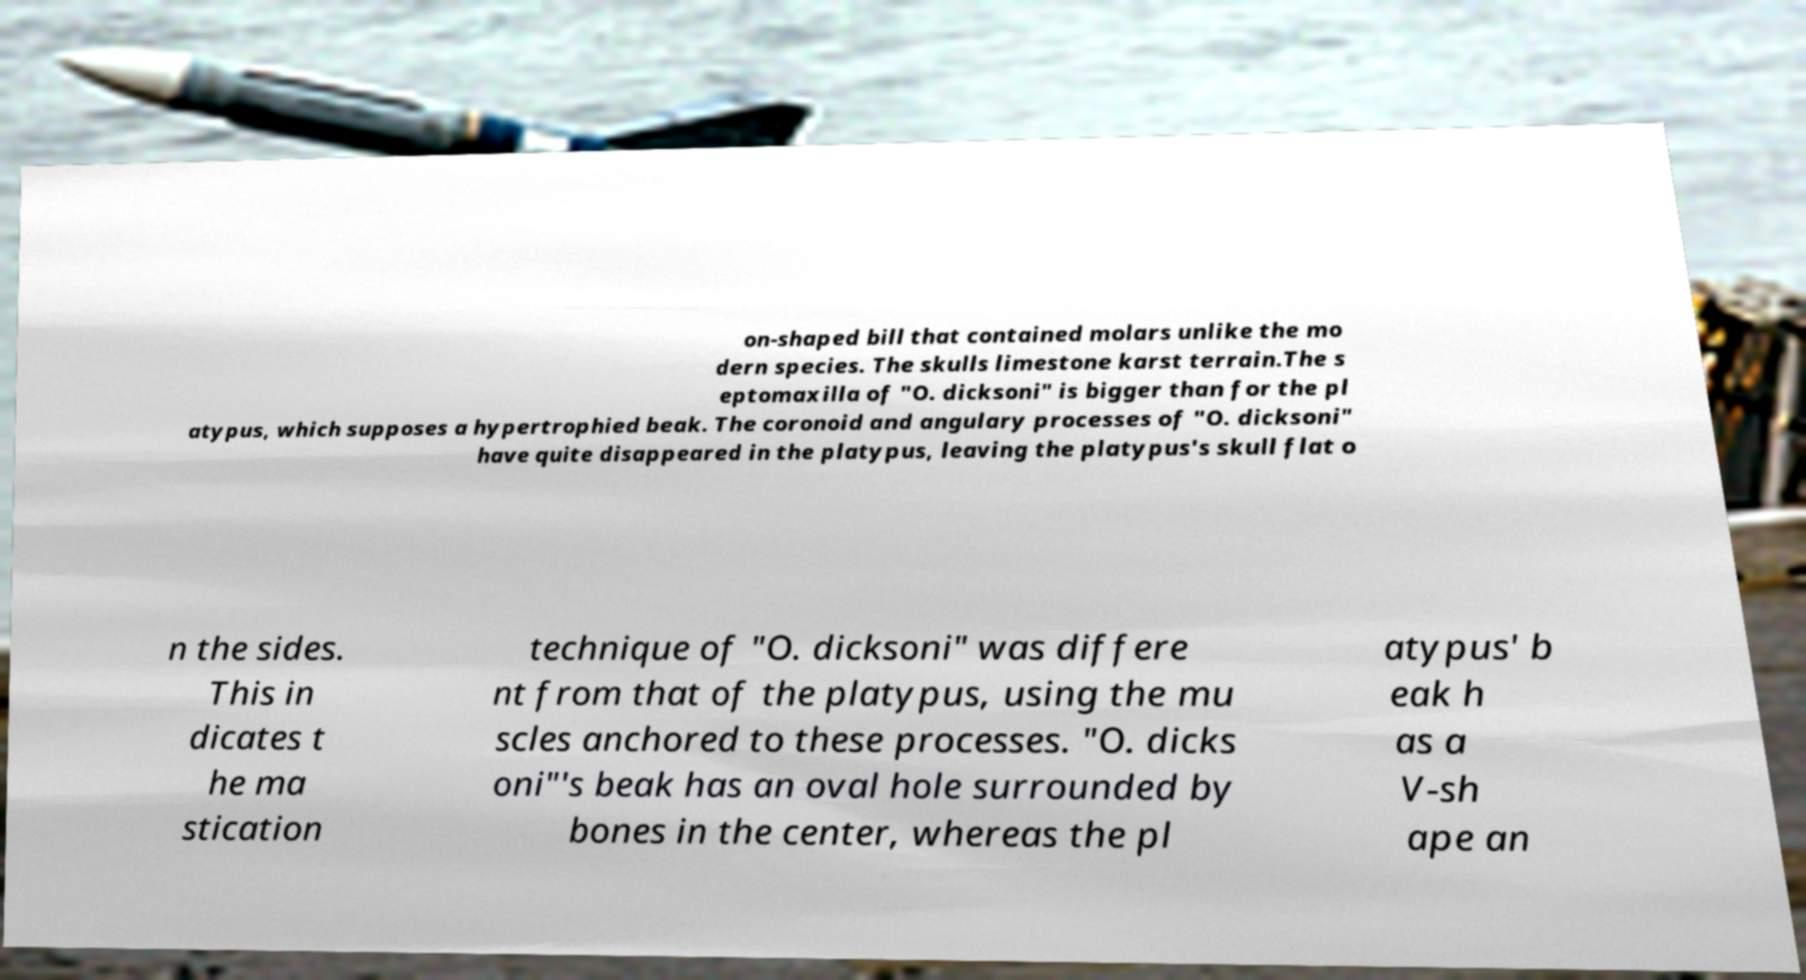Please read and relay the text visible in this image. What does it say? on-shaped bill that contained molars unlike the mo dern species. The skulls limestone karst terrain.The s eptomaxilla of "O. dicksoni" is bigger than for the pl atypus, which supposes a hypertrophied beak. The coronoid and angulary processes of "O. dicksoni" have quite disappeared in the platypus, leaving the platypus's skull flat o n the sides. This in dicates t he ma stication technique of "O. dicksoni" was differe nt from that of the platypus, using the mu scles anchored to these processes. "O. dicks oni"'s beak has an oval hole surrounded by bones in the center, whereas the pl atypus' b eak h as a V-sh ape an 